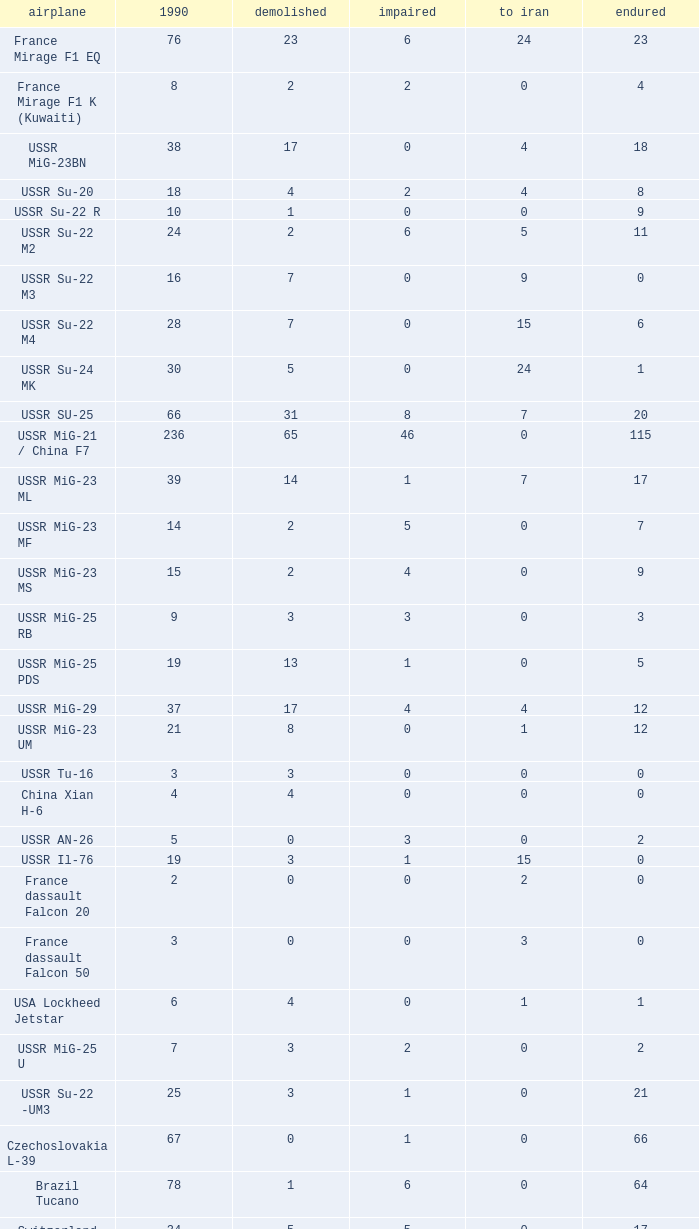Given that 4 people journeyed to iran and less than 12.0 of them made it out alive, what was their number in 1990? 1.0. I'm looking to parse the entire table for insights. Could you assist me with that? {'header': ['airplane', '1990', 'demolished', 'impaired', 'to iran', 'endured'], 'rows': [['France Mirage F1 EQ', '76', '23', '6', '24', '23'], ['France Mirage F1 K (Kuwaiti)', '8', '2', '2', '0', '4'], ['USSR MiG-23BN', '38', '17', '0', '4', '18'], ['USSR Su-20', '18', '4', '2', '4', '8'], ['USSR Su-22 R', '10', '1', '0', '0', '9'], ['USSR Su-22 M2', '24', '2', '6', '5', '11'], ['USSR Su-22 M3', '16', '7', '0', '9', '0'], ['USSR Su-22 M4', '28', '7', '0', '15', '6'], ['USSR Su-24 MK', '30', '5', '0', '24', '1'], ['USSR SU-25', '66', '31', '8', '7', '20'], ['USSR MiG-21 / China F7', '236', '65', '46', '0', '115'], ['USSR MiG-23 ML', '39', '14', '1', '7', '17'], ['USSR MiG-23 MF', '14', '2', '5', '0', '7'], ['USSR MiG-23 MS', '15', '2', '4', '0', '9'], ['USSR MiG-25 RB', '9', '3', '3', '0', '3'], ['USSR MiG-25 PDS', '19', '13', '1', '0', '5'], ['USSR MiG-29', '37', '17', '4', '4', '12'], ['USSR MiG-23 UM', '21', '8', '0', '1', '12'], ['USSR Tu-16', '3', '3', '0', '0', '0'], ['China Xian H-6', '4', '4', '0', '0', '0'], ['USSR AN-26', '5', '0', '3', '0', '2'], ['USSR Il-76', '19', '3', '1', '15', '0'], ['France dassault Falcon 20', '2', '0', '0', '2', '0'], ['France dassault Falcon 50', '3', '0', '0', '3', '0'], ['USA Lockheed Jetstar', '6', '4', '0', '1', '1'], ['USSR MiG-25 U', '7', '3', '2', '0', '2'], ['USSR Su-22 -UM3', '25', '3', '1', '0', '21'], ['Czechoslovakia L-39', '67', '0', '1', '0', '66'], ['Brazil Tucano', '78', '1', '6', '0', '64'], ['Switzerland FFA AS-202 Bravo', '34', '5', '5', '0', '17'], ['Eloris trainer', '12', '0', '0', '0', '12'], ['United Kingdom Jet Provost', '15', '0', '0', '0', '15'], ['BK-117', '14', '1', '6', '0', '6'], ['France Mirage F1 BQ', '10', '0', '0', '0', '10']]} 